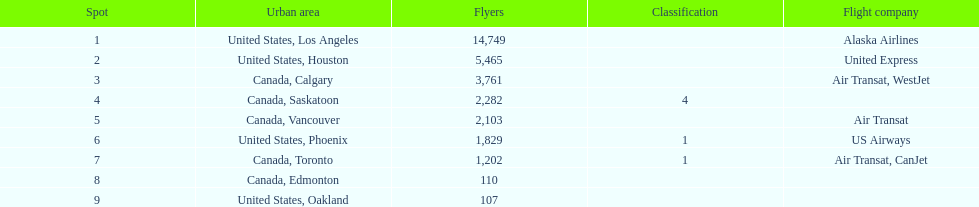I'm looking to parse the entire table for insights. Could you assist me with that? {'header': ['Spot', 'Urban area', 'Flyers', 'Classification', 'Flight company'], 'rows': [['1', 'United States, Los Angeles', '14,749', '', 'Alaska Airlines'], ['2', 'United States, Houston', '5,465', '', 'United Express'], ['3', 'Canada, Calgary', '3,761', '', 'Air Transat, WestJet'], ['4', 'Canada, Saskatoon', '2,282', '4', ''], ['5', 'Canada, Vancouver', '2,103', '', 'Air Transat'], ['6', 'United States, Phoenix', '1,829', '1', 'US Airways'], ['7', 'Canada, Toronto', '1,202', '1', 'Air Transat, CanJet'], ['8', 'Canada, Edmonton', '110', '', ''], ['9', 'United States, Oakland', '107', '', '']]} What is the average number of passengers in the united states? 5537.5. 